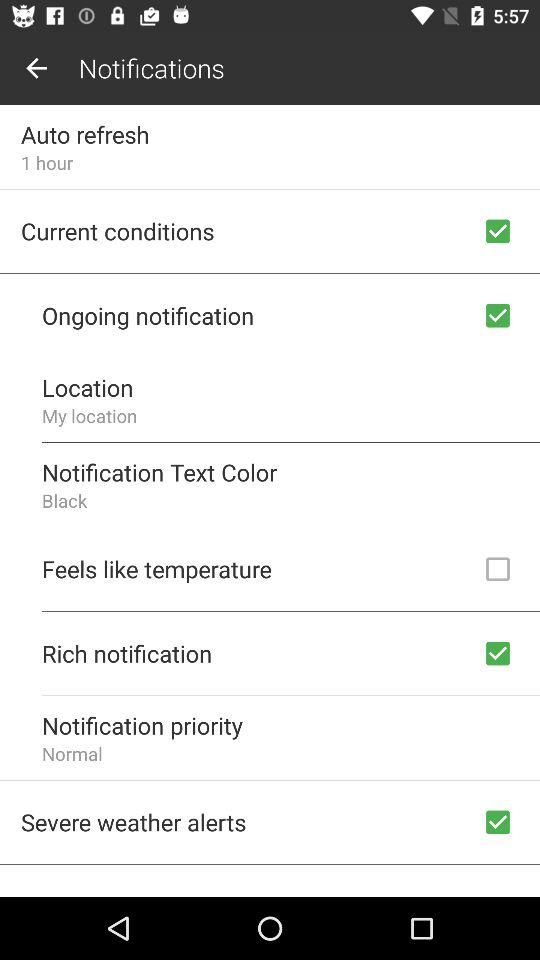What is the notification text color? The notification text color is black. 